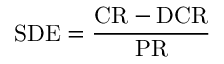<formula> <loc_0><loc_0><loc_500><loc_500>S D E = \frac { C R - D C R } { P R }</formula> 